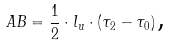Convert formula to latex. <formula><loc_0><loc_0><loc_500><loc_500>A B = \frac { 1 } { 2 } \cdot l _ { u } \cdot ( \tau _ { 2 } - \tau _ { 0 } ) \, \text {,}</formula> 